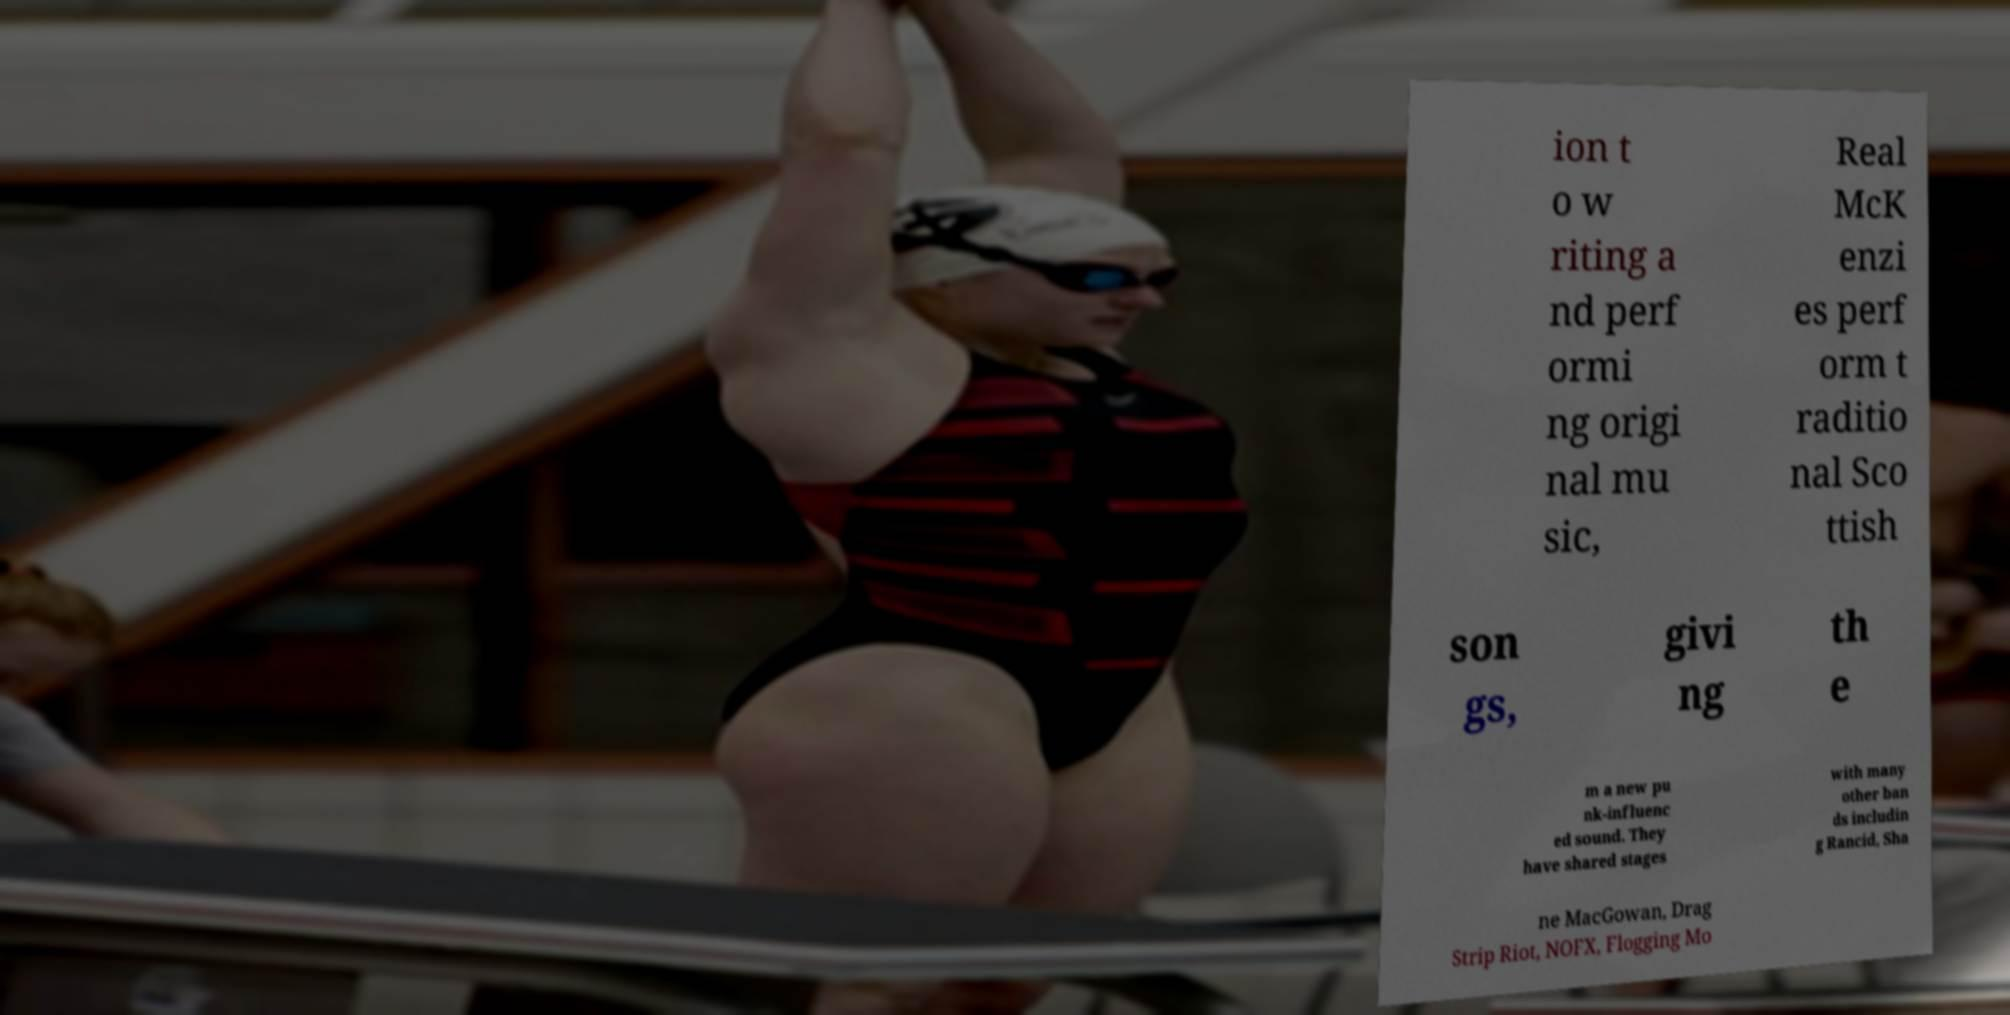Please identify and transcribe the text found in this image. ion t o w riting a nd perf ormi ng origi nal mu sic, Real McK enzi es perf orm t raditio nal Sco ttish son gs, givi ng th e m a new pu nk-influenc ed sound. They have shared stages with many other ban ds includin g Rancid, Sha ne MacGowan, Drag Strip Riot, NOFX, Flogging Mo 